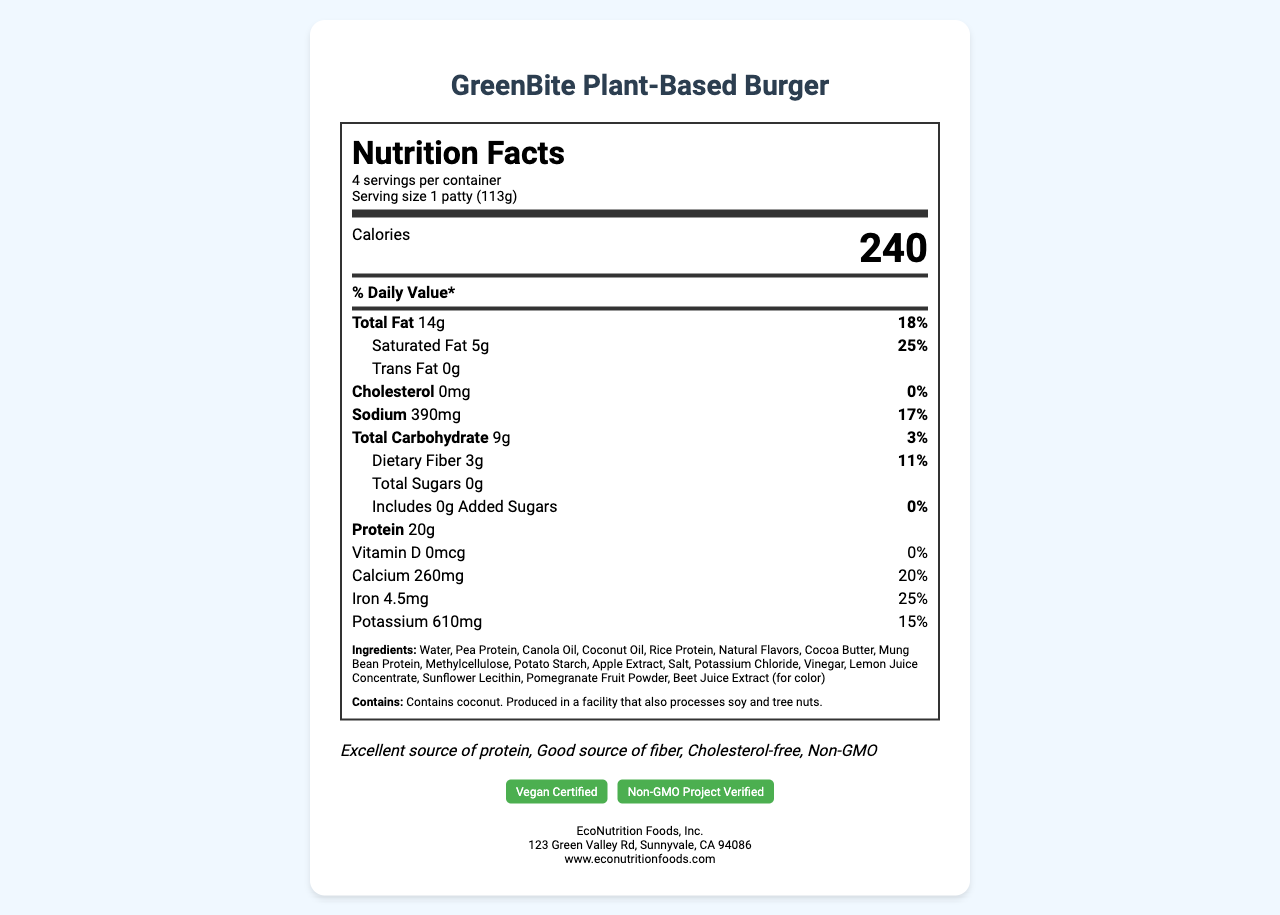what is the serving size for the GreenBite Plant-Based Burger? The serving size is listed directly under the product name in the document.
Answer: 1 patty (113g) how many calories are there per serving? The number of calories is prominently displayed in large, bold font towards the top of the nutrition facts section.
Answer: 240 how much protein is in one serving? The protein amount is stated in the nutrient breakdown section.
Answer: 20g what is the amount of saturated fat per serving? The saturated fat amount is listed under the Total Fat section.
Answer: 5g How much dietary fiber does one patty contain? The dietary fiber is listed under Total Carbohydrate in the nutrition facts section.
Answer: 3g which company manufactures the GreenBite Plant-Based Burger? A. GreenBite Foods, Inc. B. Sustainable Nutrition LLC C. EcoNutrition Foods, Inc. D. Plant Power Enterprises The company information section at the bottom lists EcoNutrition Foods, Inc. as the manufacturer.
Answer: C which of the following health claims is NOT made by the GreenBite Plant-Based Burger? A. Excellent source of protein B. Good source of fiber C. Sugar-free D. Cholesterol-free The document lists "Excellent source of protein," "Good source of fiber," and "Cholesterol-free" as health claims, but "Sugar-free" is not mentioned.
Answer: C Does the product contain coconut? The allergen information clearly states that the product contains coconut.
Answer: Yes Does the GreenBite Plant-Based Burger include any added sugars? The nutrition facts section lists 0g of added sugars.
Answer: No Can the document help determine the price of the GreenBite Plant-Based Burger? The document does not include any pricing information.
Answer: Cannot be determined describe the main features presented in the document The document comprehensively covers nutritional information, allergen details, health benefits, certifications, company, and preparation-related instructions for the product.
Answer: The document provides a detailed Nutrition Facts label for the GreenBite Plant-Based Burger, including serving size, calorie count, and nutrient breakdown per serving. It also lists ingredients, allergen information, health claims, certification logos, and company details. Storage and cooking instructions, as well as sustainability information about the packaging, are also included. What is the percentage daily value of calcium in one serving? The percentage daily value for calcium is listed in the nutrition facts section.
Answer: 20% is the product free from cholesterol and trans fats? The document lists 0mg of cholesterol and 0g of trans fats per serving.
Answer: Yes 